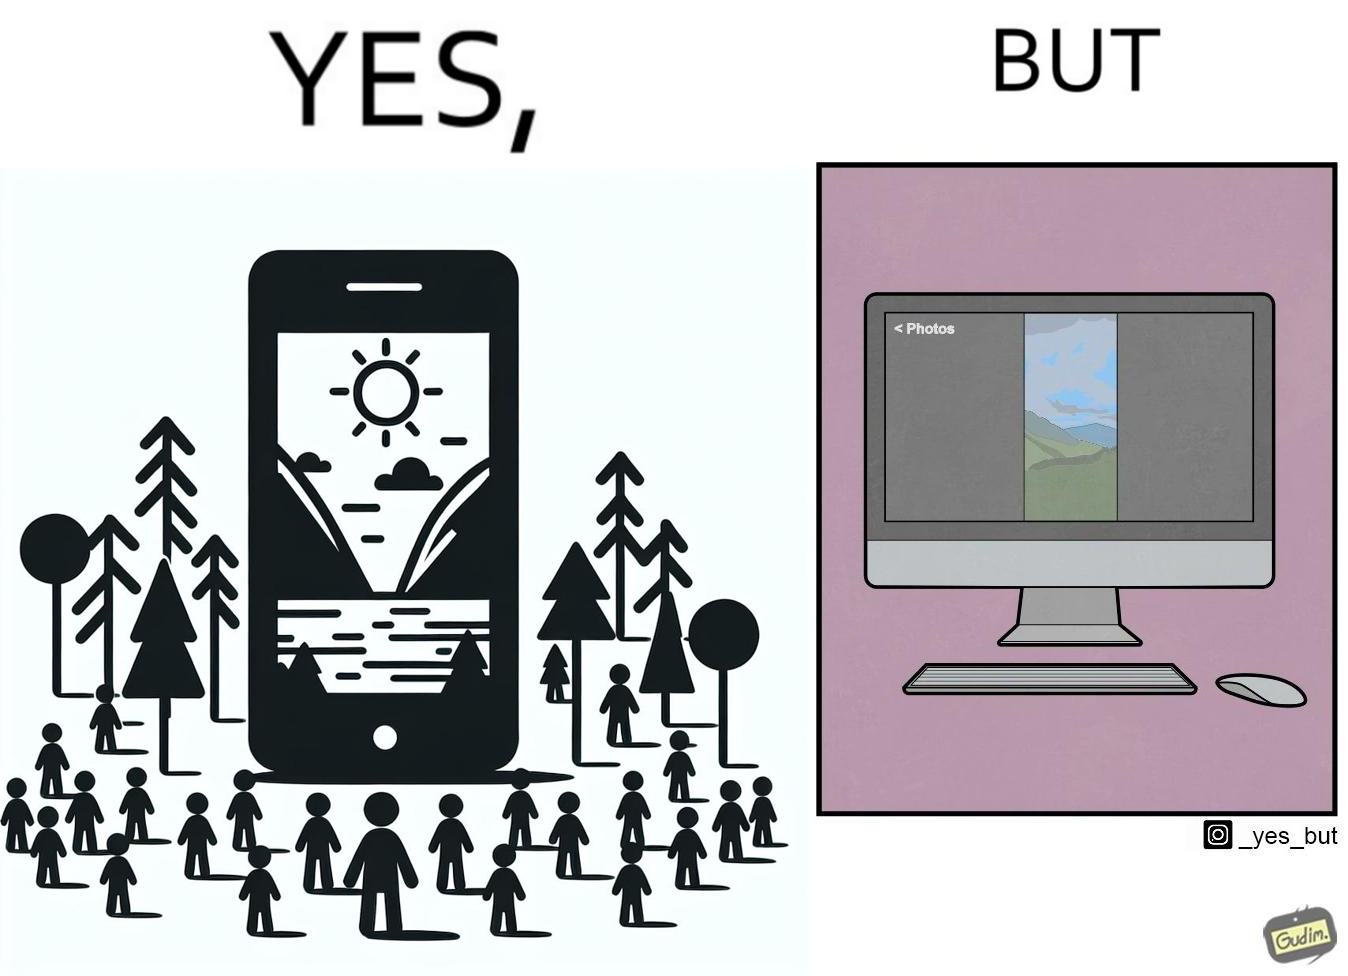Explain why this image is satirical. This image is funny, as when using the "photos" app on mobile, it shows you images perfectly, which fill the entire screen, but when viewing the same photos on the computer monitor, the same images have a very limited coverage of the screen. 